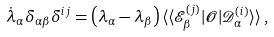<formula> <loc_0><loc_0><loc_500><loc_500>\dot { \lambda } _ { \alpha } \delta _ { \alpha \beta } \delta ^ { i j } = \left ( \lambda _ { \alpha } - \lambda _ { \beta } \right ) \langle \langle \mathcal { E } _ { \beta } ^ { ( j ) } | \mathcal { O } | \mathcal { D } _ { \alpha } ^ { ( i ) } \rangle \rangle \, ,</formula> 